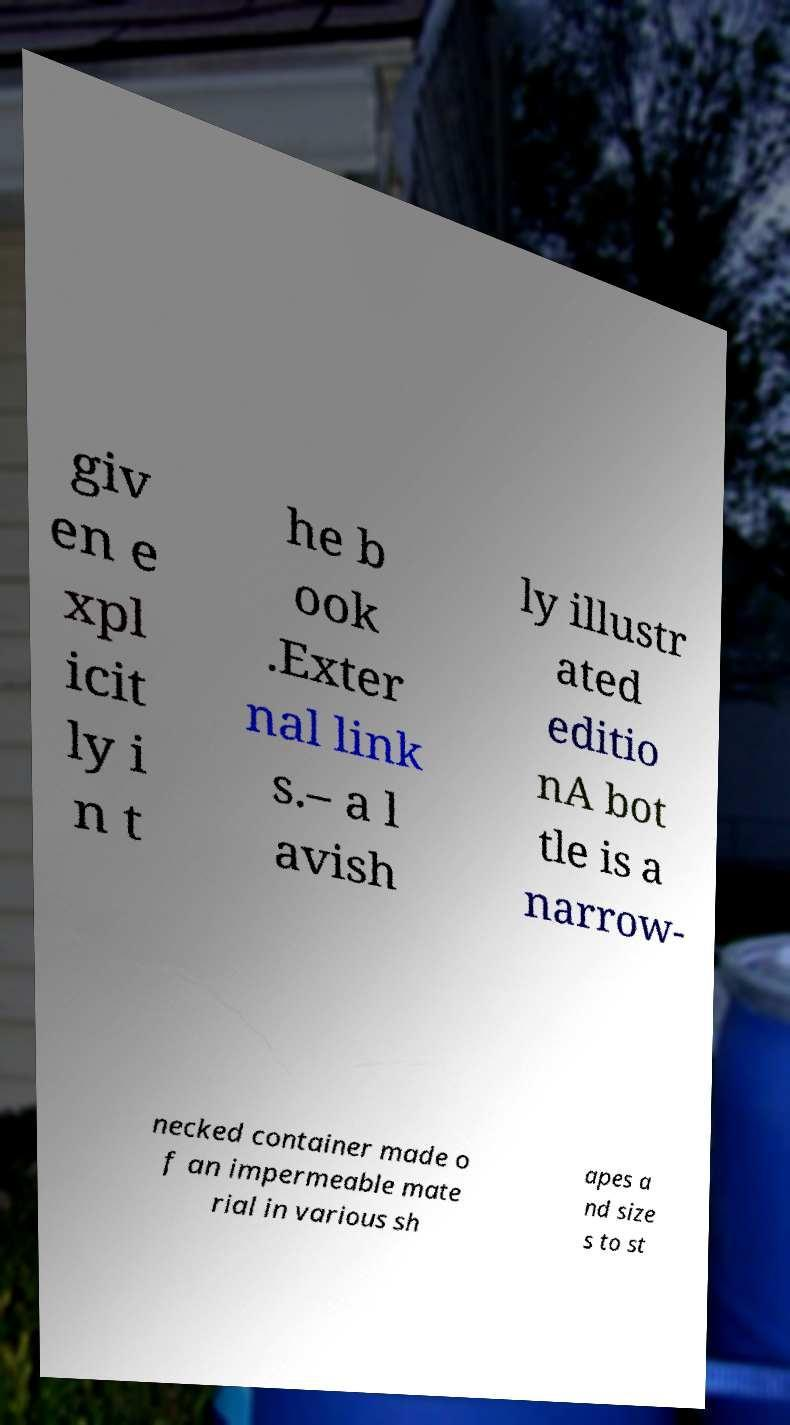Could you assist in decoding the text presented in this image and type it out clearly? giv en e xpl icit ly i n t he b ook .Exter nal link s.– a l avish ly illustr ated editio nA bot tle is a narrow- necked container made o f an impermeable mate rial in various sh apes a nd size s to st 